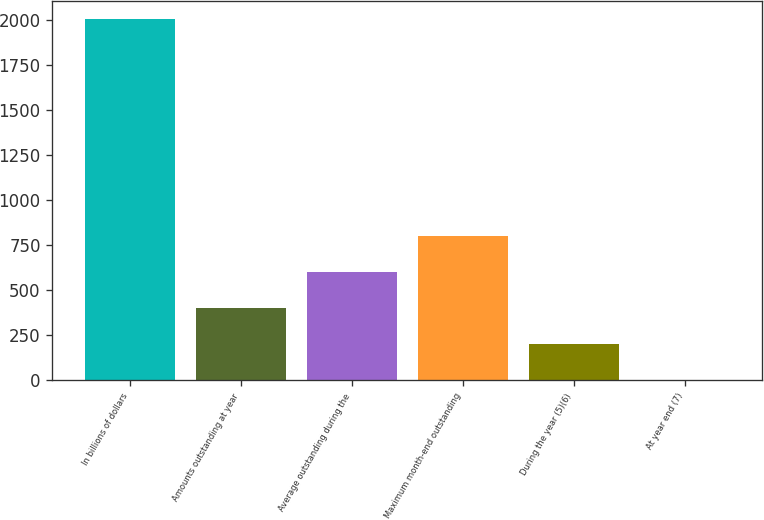Convert chart to OTSL. <chart><loc_0><loc_0><loc_500><loc_500><bar_chart><fcel>In billions of dollars<fcel>Amounts outstanding at year<fcel>Average outstanding during the<fcel>Maximum month-end outstanding<fcel>During the year (5)(6)<fcel>At year end (7)<nl><fcel>2009<fcel>402.08<fcel>602.95<fcel>803.82<fcel>201.21<fcel>0.34<nl></chart> 